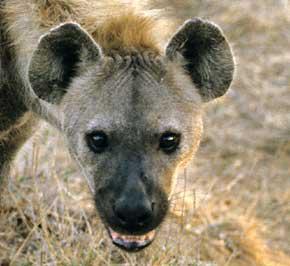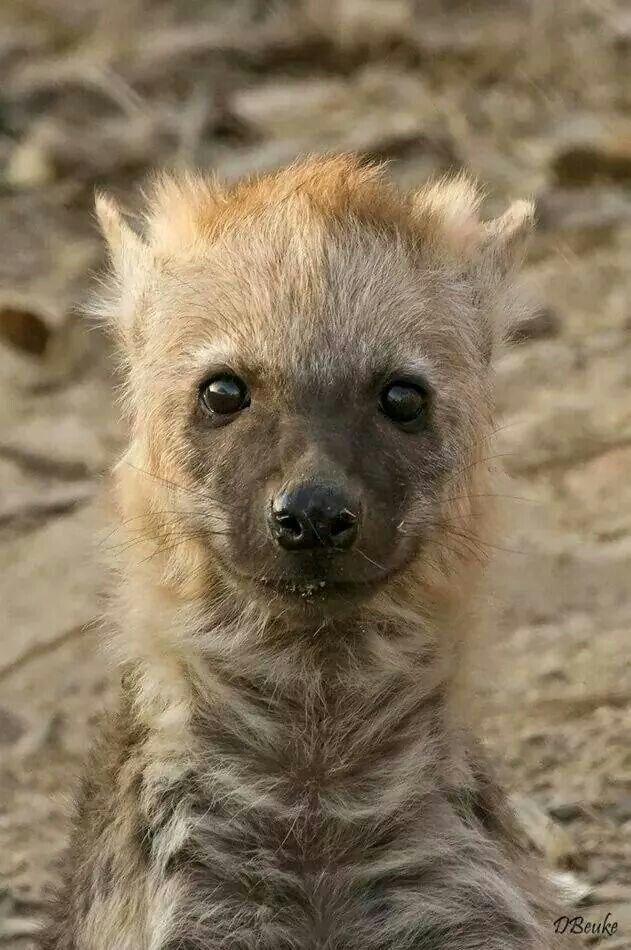The first image is the image on the left, the second image is the image on the right. Considering the images on both sides, is "The body of the hyena on the left image is facing left" valid? Answer yes or no. No. 